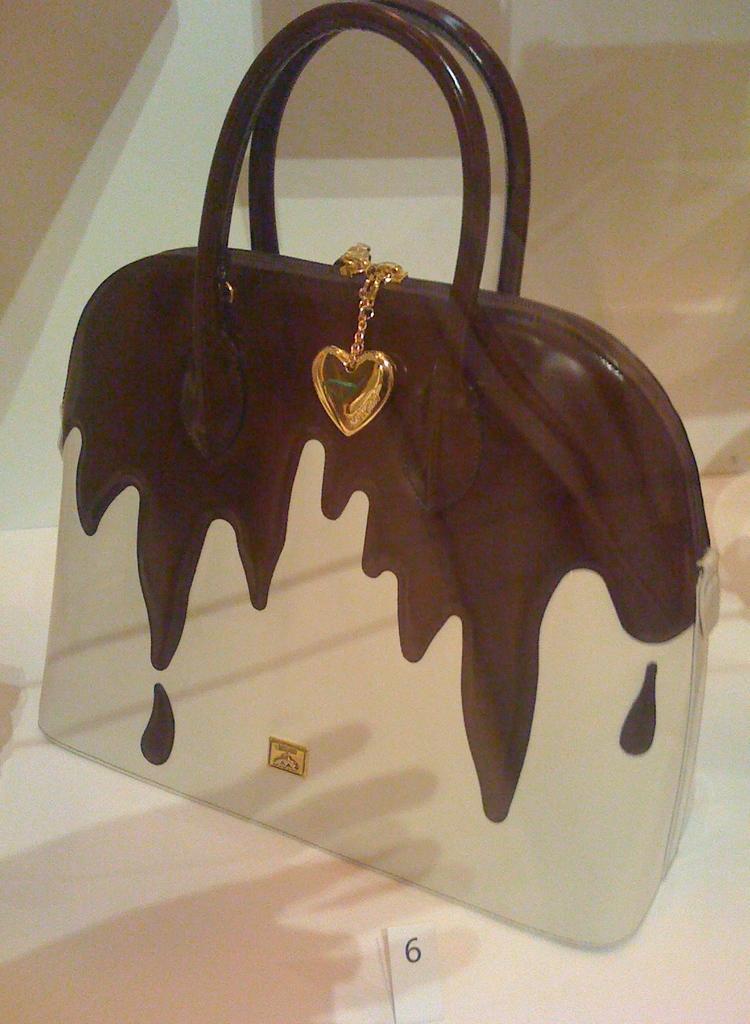Please provide a concise description of this image. In this picture their is a hand bag and a locket attached to it,which is kept on a floor. 